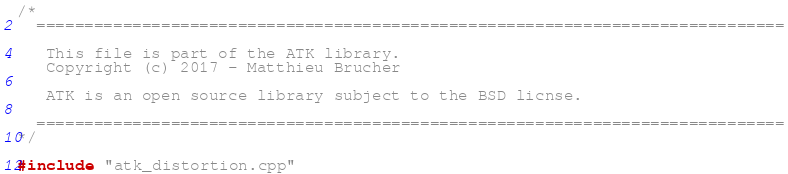<code> <loc_0><loc_0><loc_500><loc_500><_ObjectiveC_>/*
  ==============================================================================

   This file is part of the ATK library.
   Copyright (c) 2017 - Matthieu Brucher

   ATK is an open source library subject to the BSD licnse.

  ==============================================================================
*/

#include "atk_distortion.cpp"
</code> 